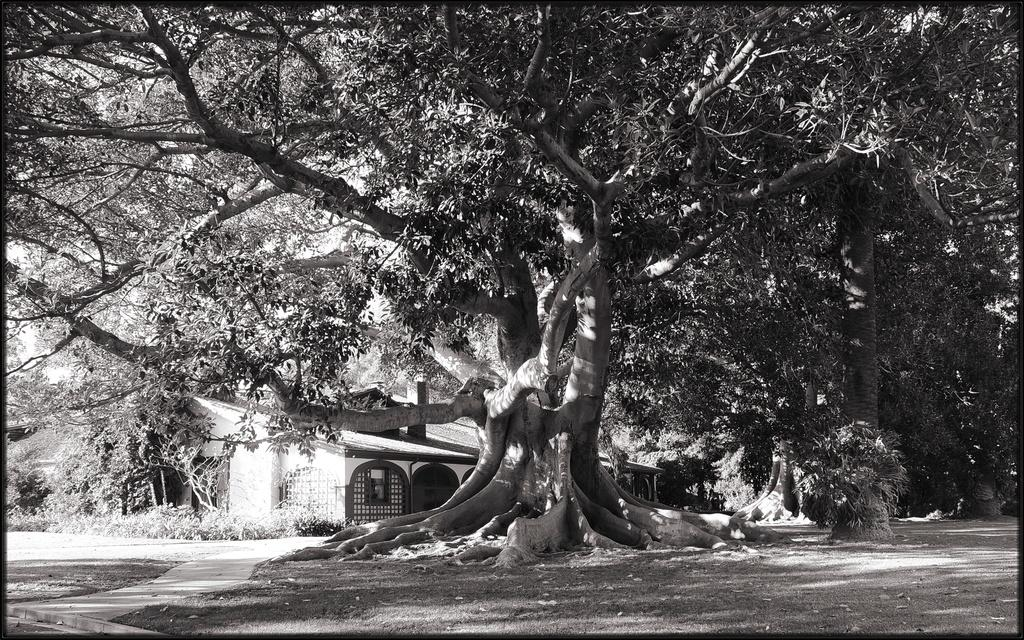What is the color scheme of the image? The image is black and white. What is the main subject in the middle of the image? There is a big tree in the middle of the image. What structure is located behind the tree? There is a house behind the tree. What can be seen at the bottom of the image? The ground is visible at the bottom of the image. Where is the tent set up in the image? There is no tent present in the image. What type of spoon can be seen in the image? There are no spoons present in the image. 